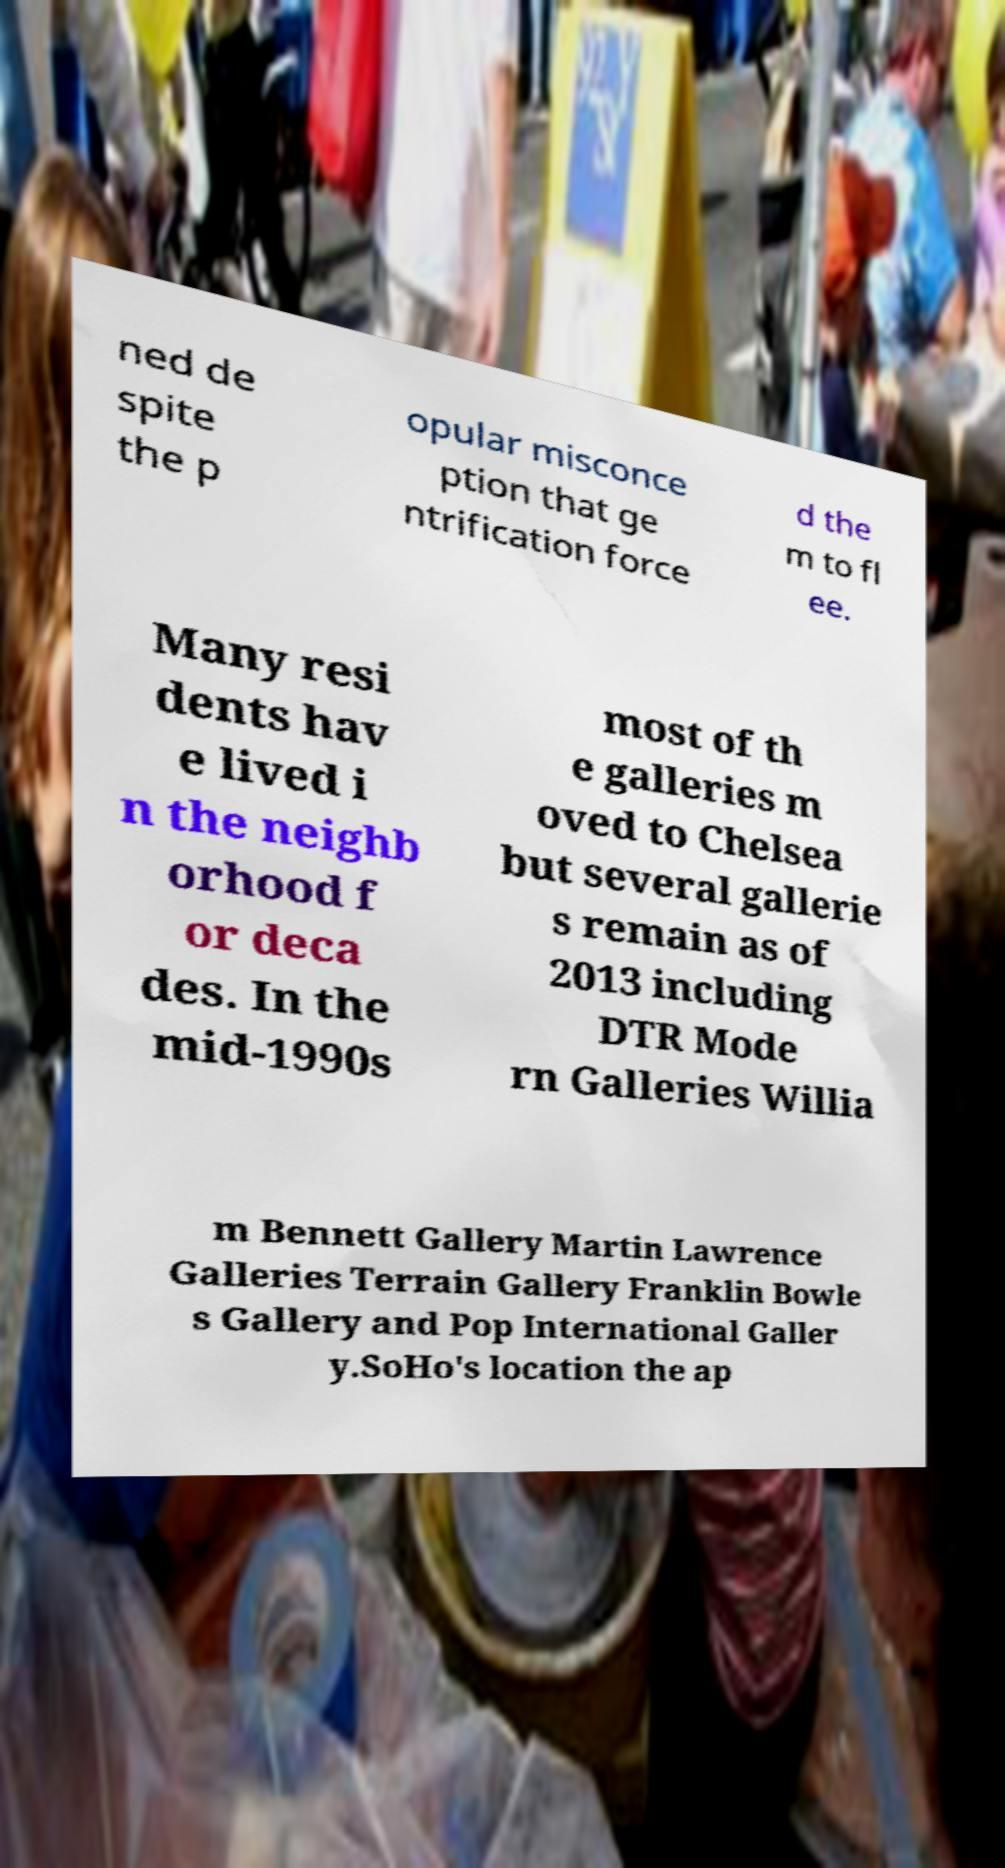Could you extract and type out the text from this image? ned de spite the p opular misconce ption that ge ntrification force d the m to fl ee. Many resi dents hav e lived i n the neighb orhood f or deca des. In the mid-1990s most of th e galleries m oved to Chelsea but several gallerie s remain as of 2013 including DTR Mode rn Galleries Willia m Bennett Gallery Martin Lawrence Galleries Terrain Gallery Franklin Bowle s Gallery and Pop International Galler y.SoHo's location the ap 